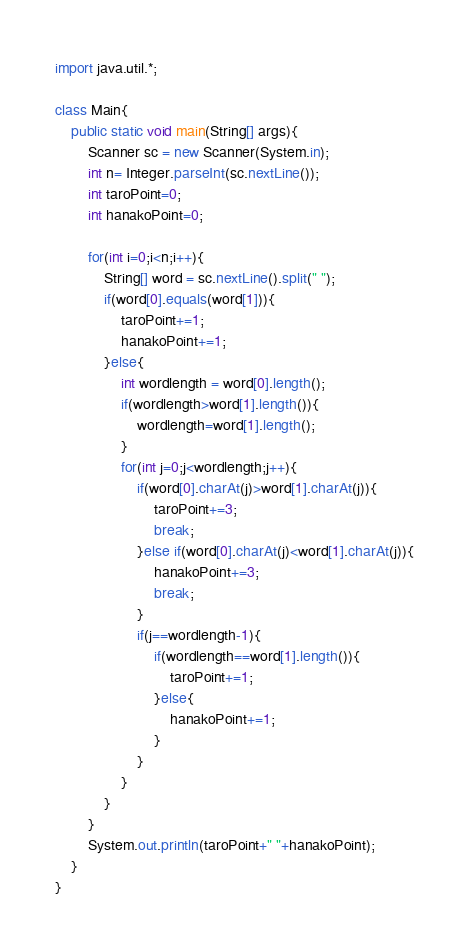Convert code to text. <code><loc_0><loc_0><loc_500><loc_500><_Java_>import java.util.*;

class Main{
	public static void main(String[] args){
		Scanner sc = new Scanner(System.in);
		int n= Integer.parseInt(sc.nextLine());
		int taroPoint=0;
		int hanakoPoint=0;
		
		for(int i=0;i<n;i++){
			String[] word = sc.nextLine().split(" ");
			if(word[0].equals(word[1])){
				taroPoint+=1;
				hanakoPoint+=1;
			}else{
				int wordlength = word[0].length();
				if(wordlength>word[1].length()){
					wordlength=word[1].length();
				}
				for(int j=0;j<wordlength;j++){
					if(word[0].charAt(j)>word[1].charAt(j)){
						taroPoint+=3;
						break;
					}else if(word[0].charAt(j)<word[1].charAt(j)){
						hanakoPoint+=3;
						break;
					}
					if(j==wordlength-1){
						if(wordlength==word[1].length()){
							taroPoint+=1;
						}else{
							hanakoPoint+=1;
						}
					}
				}
			}
		}
		System.out.println(taroPoint+" "+hanakoPoint);
	}
}</code> 